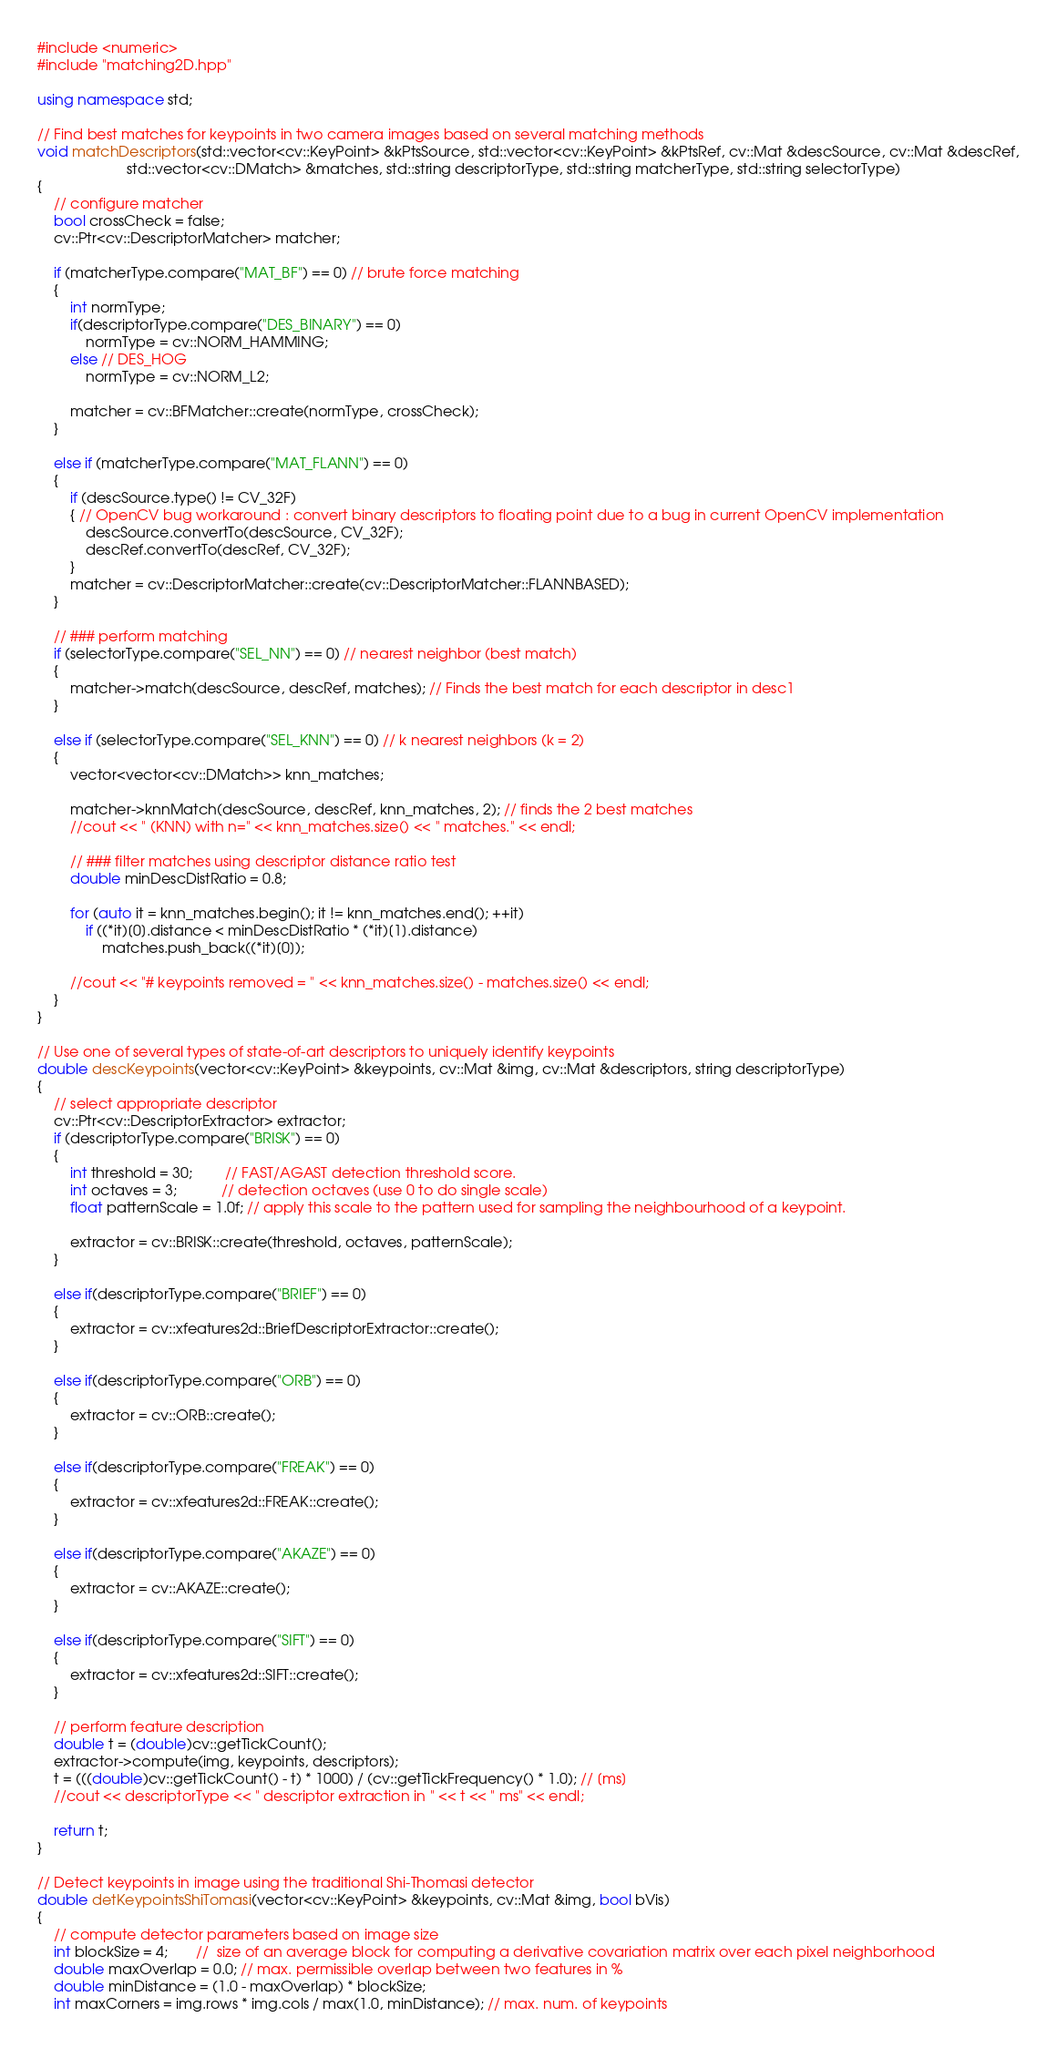<code> <loc_0><loc_0><loc_500><loc_500><_C++_>#include <numeric>
#include "matching2D.hpp"

using namespace std;

// Find best matches for keypoints in two camera images based on several matching methods
void matchDescriptors(std::vector<cv::KeyPoint> &kPtsSource, std::vector<cv::KeyPoint> &kPtsRef, cv::Mat &descSource, cv::Mat &descRef,
                      std::vector<cv::DMatch> &matches, std::string descriptorType, std::string matcherType, std::string selectorType)
{
    // configure matcher
    bool crossCheck = false;
    cv::Ptr<cv::DescriptorMatcher> matcher;

    if (matcherType.compare("MAT_BF") == 0) // brute force matching
    {
        int normType;
        if(descriptorType.compare("DES_BINARY") == 0)
            normType = cv::NORM_HAMMING;
        else // DES_HOG
            normType = cv::NORM_L2;

        matcher = cv::BFMatcher::create(normType, crossCheck);
    }

    else if (matcherType.compare("MAT_FLANN") == 0)
    {
        if (descSource.type() != CV_32F)
        { // OpenCV bug workaround : convert binary descriptors to floating point due to a bug in current OpenCV implementation
            descSource.convertTo(descSource, CV_32F);
            descRef.convertTo(descRef, CV_32F);
        }
        matcher = cv::DescriptorMatcher::create(cv::DescriptorMatcher::FLANNBASED);
    }

    // ### perform matching
    if (selectorType.compare("SEL_NN") == 0) // nearest neighbor (best match)
    {
        matcher->match(descSource, descRef, matches); // Finds the best match for each descriptor in desc1
    }

    else if (selectorType.compare("SEL_KNN") == 0) // k nearest neighbors (k = 2)
    {
        vector<vector<cv::DMatch>> knn_matches;

        matcher->knnMatch(descSource, descRef, knn_matches, 2); // finds the 2 best matches
        //cout << " (KNN) with n=" << knn_matches.size() << " matches." << endl;

        // ### filter matches using descriptor distance ratio test
        double minDescDistRatio = 0.8;

        for (auto it = knn_matches.begin(); it != knn_matches.end(); ++it)
            if ((*it)[0].distance < minDescDistRatio * (*it)[1].distance)
                matches.push_back((*it)[0]);

        //cout << "# keypoints removed = " << knn_matches.size() - matches.size() << endl;
    }
}

// Use one of several types of state-of-art descriptors to uniquely identify keypoints
double descKeypoints(vector<cv::KeyPoint> &keypoints, cv::Mat &img, cv::Mat &descriptors, string descriptorType)
{
    // select appropriate descriptor
    cv::Ptr<cv::DescriptorExtractor> extractor;
    if (descriptorType.compare("BRISK") == 0)
    {
        int threshold = 30;        // FAST/AGAST detection threshold score.
        int octaves = 3;           // detection octaves (use 0 to do single scale)
        float patternScale = 1.0f; // apply this scale to the pattern used for sampling the neighbourhood of a keypoint.

        extractor = cv::BRISK::create(threshold, octaves, patternScale);
    }

    else if(descriptorType.compare("BRIEF") == 0)
    {
        extractor = cv::xfeatures2d::BriefDescriptorExtractor::create();
    }

    else if(descriptorType.compare("ORB") == 0)
    {
        extractor = cv::ORB::create();
    }

    else if(descriptorType.compare("FREAK") == 0)
    {
        extractor = cv::xfeatures2d::FREAK::create();
    }

    else if(descriptorType.compare("AKAZE") == 0)
    {
        extractor = cv::AKAZE::create();
    }

    else if(descriptorType.compare("SIFT") == 0)
    {
        extractor = cv::xfeatures2d::SIFT::create();
    }

    // perform feature description
    double t = (double)cv::getTickCount();
    extractor->compute(img, keypoints, descriptors);
    t = (((double)cv::getTickCount() - t) * 1000) / (cv::getTickFrequency() * 1.0); // [ms]
    //cout << descriptorType << " descriptor extraction in " << t << " ms" << endl;

    return t;
}

// Detect keypoints in image using the traditional Shi-Thomasi detector
double detKeypointsShiTomasi(vector<cv::KeyPoint> &keypoints, cv::Mat &img, bool bVis)
{
    // compute detector parameters based on image size
    int blockSize = 4;       //  size of an average block for computing a derivative covariation matrix over each pixel neighborhood
    double maxOverlap = 0.0; // max. permissible overlap between two features in %
    double minDistance = (1.0 - maxOverlap) * blockSize;
    int maxCorners = img.rows * img.cols / max(1.0, minDistance); // max. num. of keypoints
</code> 